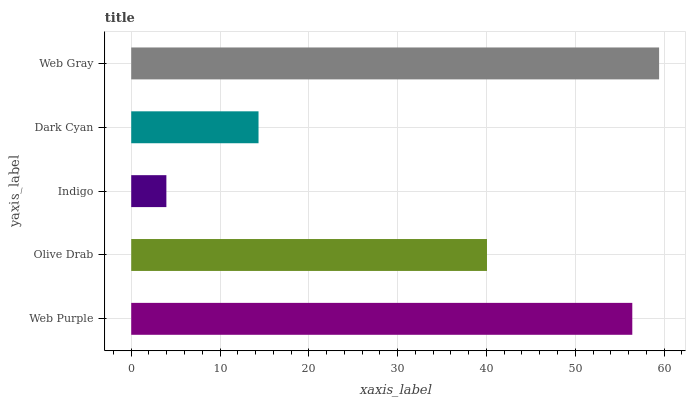Is Indigo the minimum?
Answer yes or no. Yes. Is Web Gray the maximum?
Answer yes or no. Yes. Is Olive Drab the minimum?
Answer yes or no. No. Is Olive Drab the maximum?
Answer yes or no. No. Is Web Purple greater than Olive Drab?
Answer yes or no. Yes. Is Olive Drab less than Web Purple?
Answer yes or no. Yes. Is Olive Drab greater than Web Purple?
Answer yes or no. No. Is Web Purple less than Olive Drab?
Answer yes or no. No. Is Olive Drab the high median?
Answer yes or no. Yes. Is Olive Drab the low median?
Answer yes or no. Yes. Is Indigo the high median?
Answer yes or no. No. Is Dark Cyan the low median?
Answer yes or no. No. 